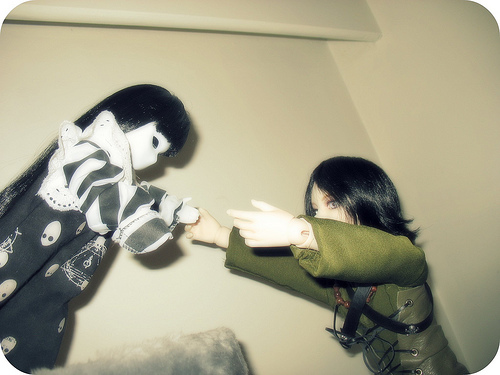<image>
Can you confirm if the doll is in front of the wall? Yes. The doll is positioned in front of the wall, appearing closer to the camera viewpoint. 